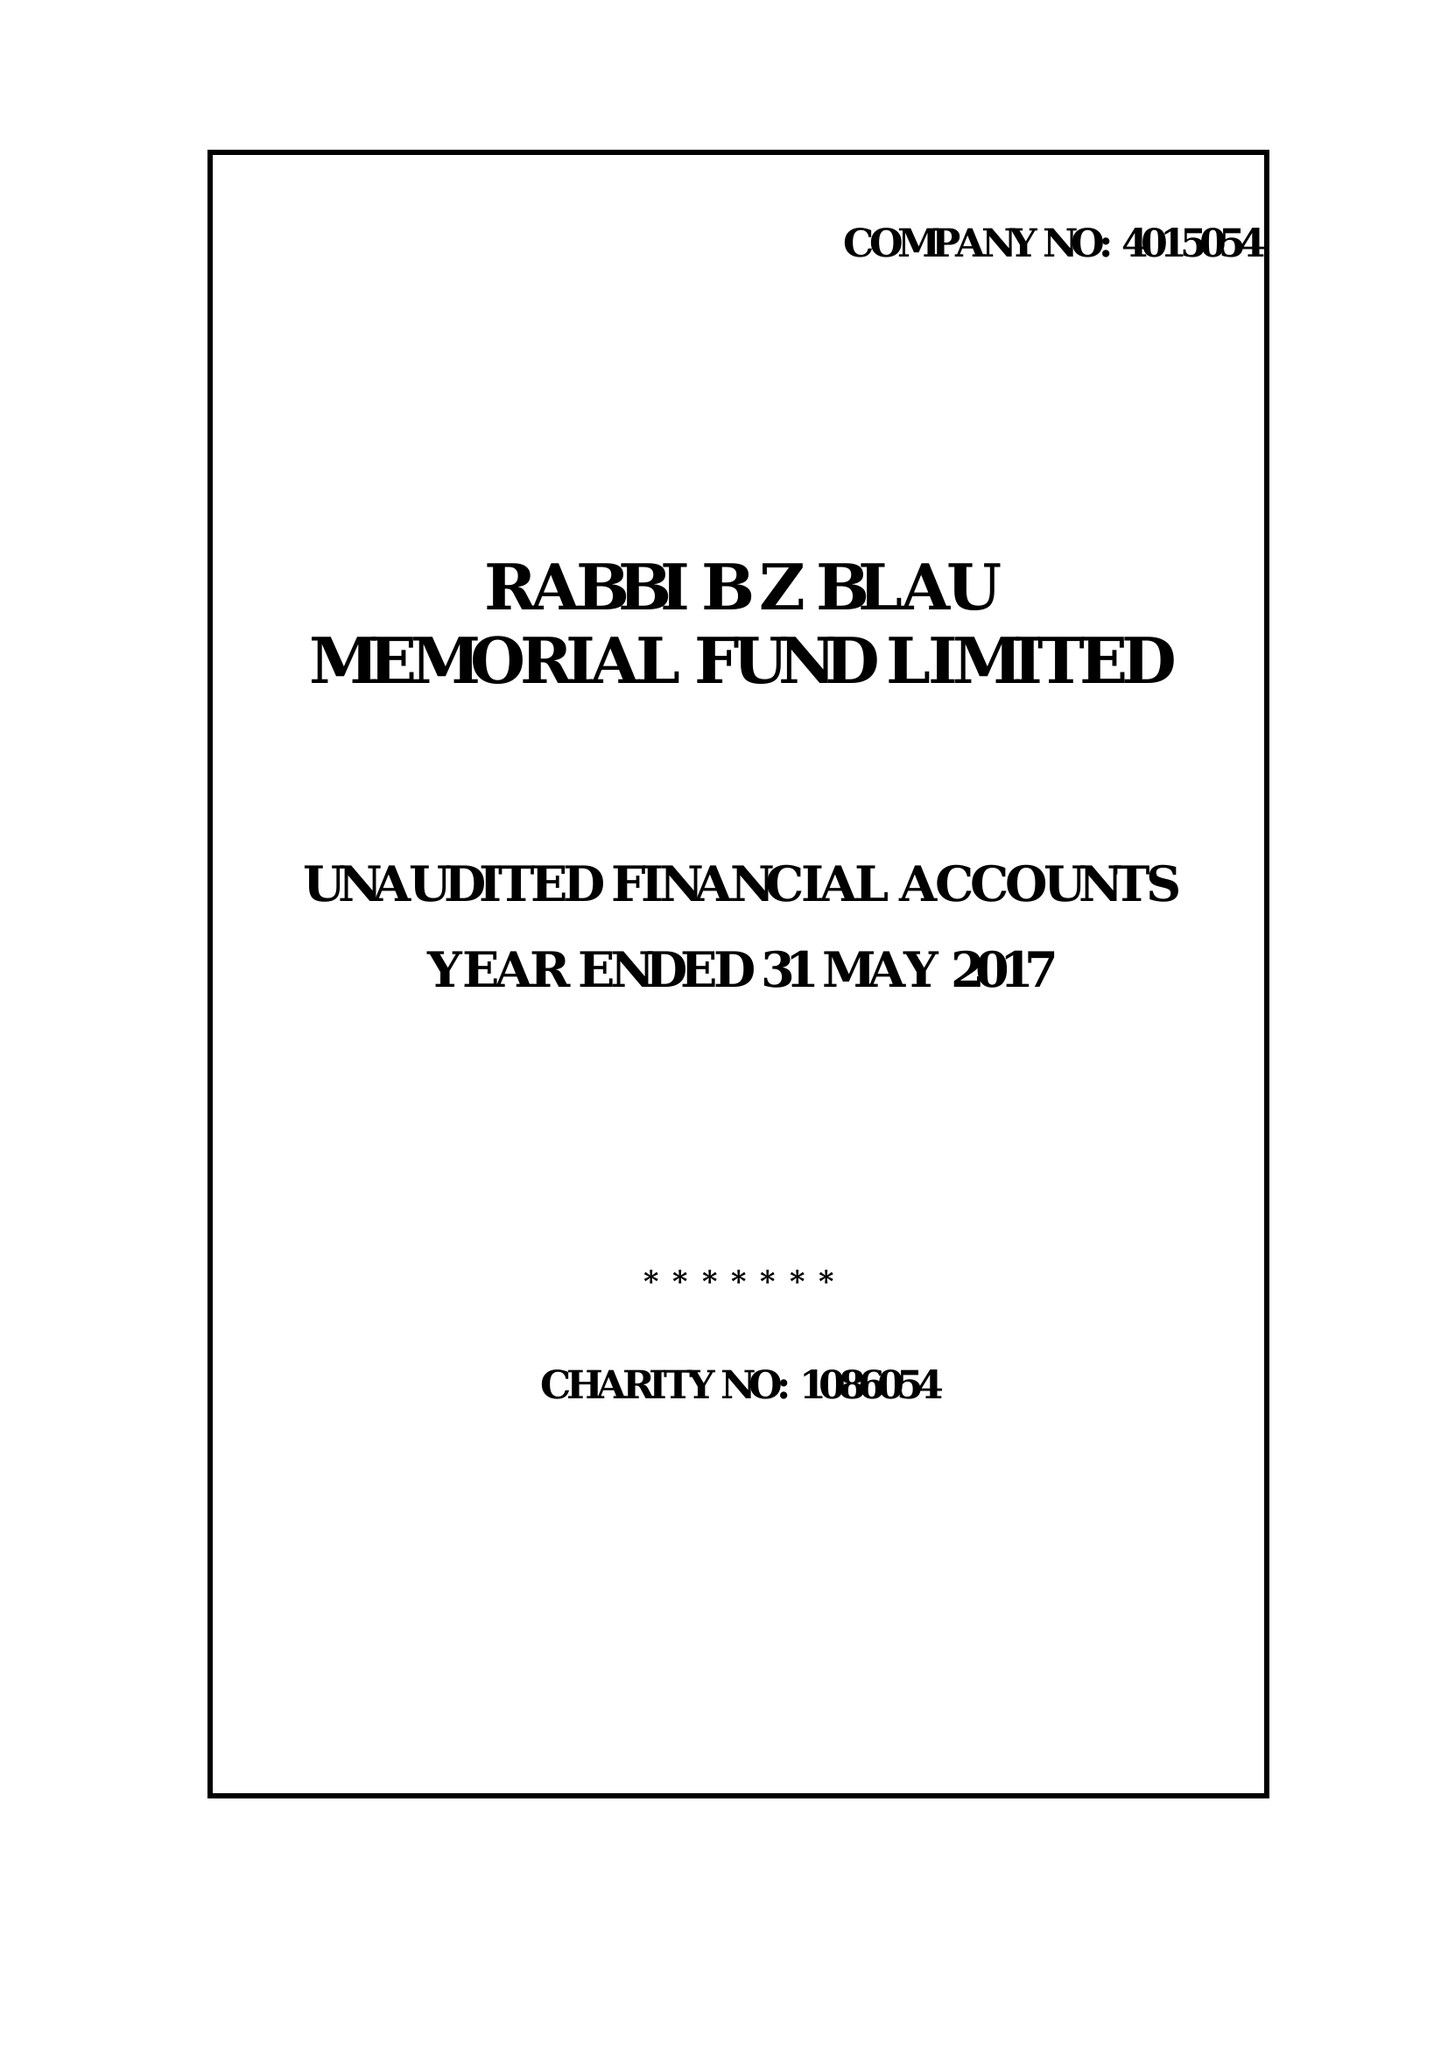What is the value for the charity_number?
Answer the question using a single word or phrase. 1086054 